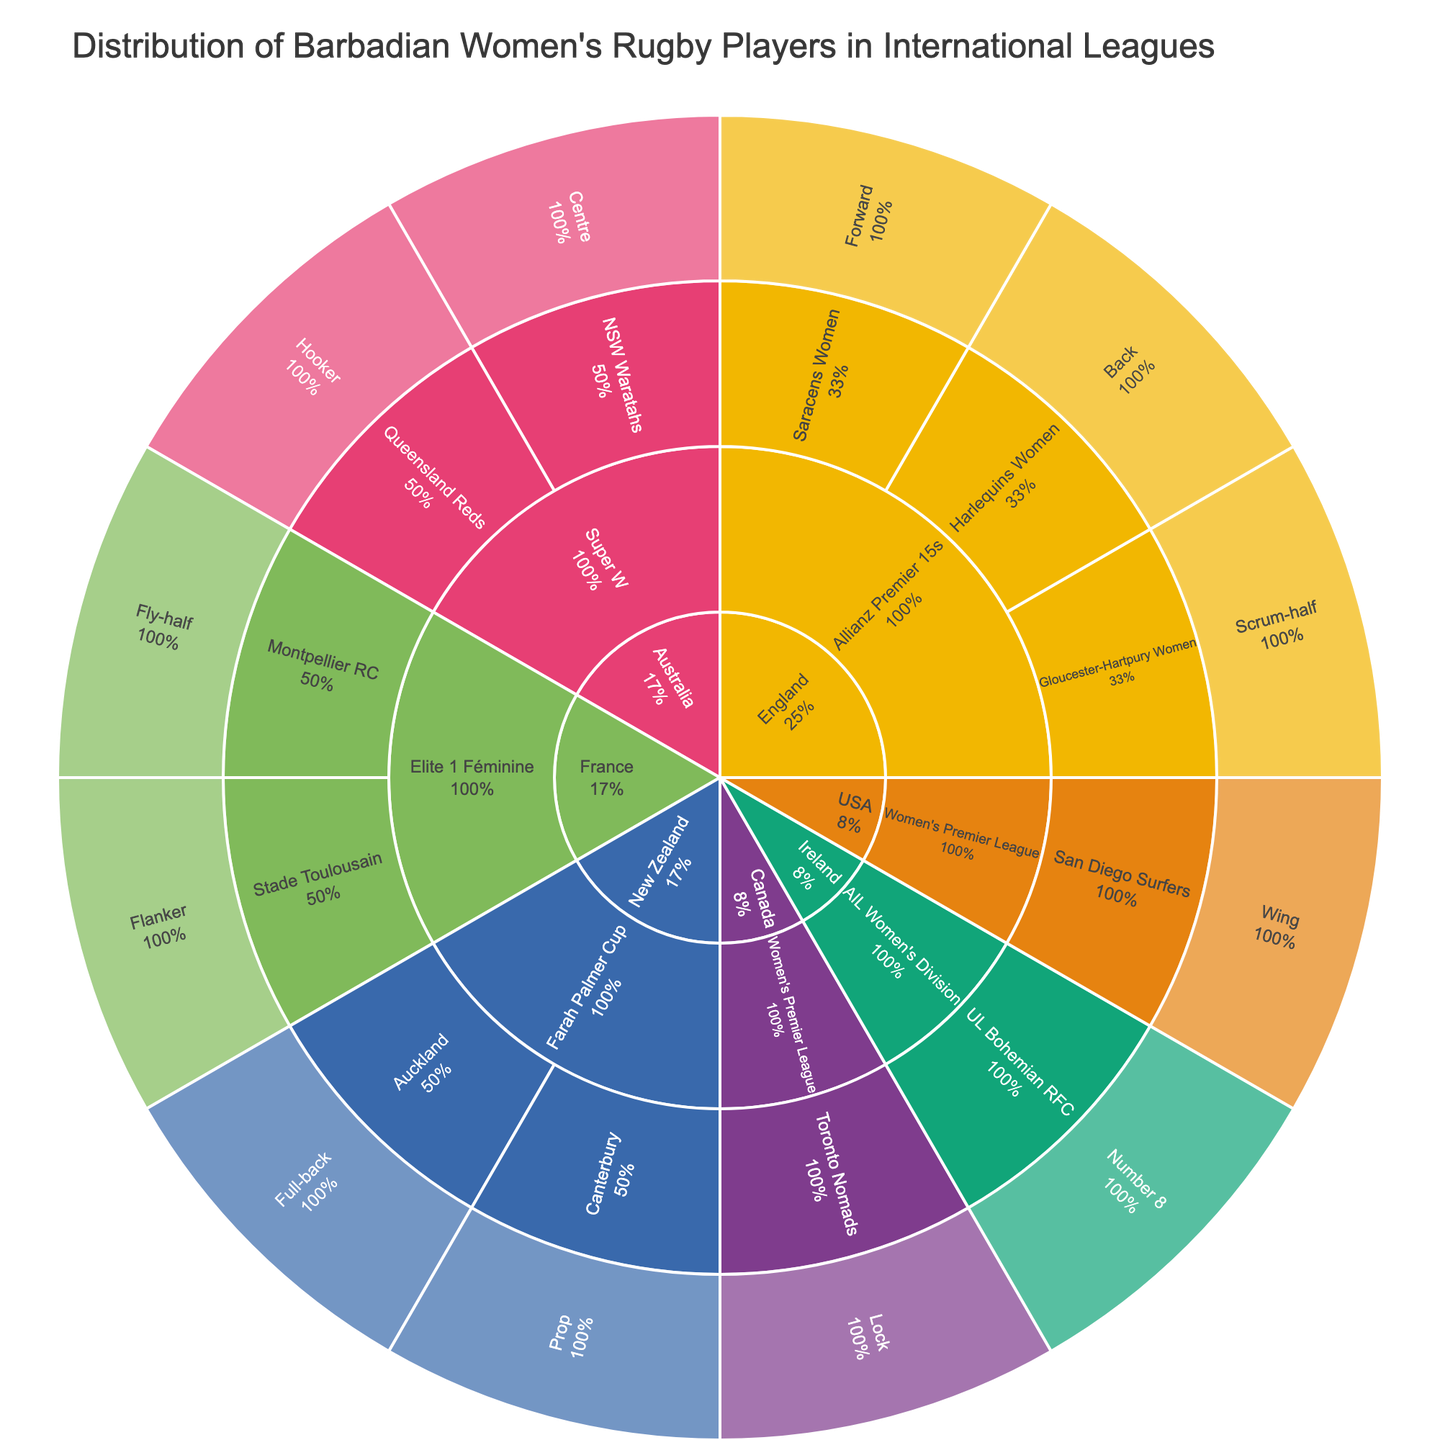How many countries have Barbadian women's rugby players in international leagues? The sunburst plot has 5 top-level segments representing countries with Barbadian women's rugby players in international leagues: England, France, New Zealand, Australia, and the USA.
Answer: 5 Which country has the most leagues with Barbadian women's rugby players? By examining the next level of the sunburst plot from the center, England has the Allianz Premier 15s league, and France has the Elite 1 Féminine league. New Zealand, Australia, Canada, and the USA have one league each. So, the country with the most leagues is England, with one league.
Answer: England Which league in New Zealand has Barbadian women rugby players, and what teams are they part of? In the sunburst plot, under New Zealand, the Farah Palmer Cup league is listed. The two teams under this league are Canterbury and Auckland.
Answer: Farah Palmer Cup, Canterbury, Auckland How many different roles are represented in the Allianz Premier 15s league? By navigating from England to the Allianz Premier 15s segment in the sunburst plot and further to teams, it can be observed that the roles include Forward (Saracens Women), Back (Harlequins Women), and Scrum-half (Gloucester-Hartpury Women). This totals three distinct roles.
Answer: 3 Which team in France has a Barbadian player in the Flanker position? In the sunburst plot, under France, then under the Elite 1 Féminine league, the Stade Toulousain team is listed, showing the Flanker role.
Answer: Stade Toulousain Are there more forwards or backs in the Allianz Premier 15s league? From the sunburst plot under England and Allianz Premier 15s league, there is one Forward (Saracens Women) and one Back (Harlequins Women). Thus, there are as many Forwards as there are Backs.
Answer: Equal Which team in Australia has a Barbadian player in the Centre role? In the sunburst plot, under Australia and the Super W league, the NSW Waratahs team is listed with the Centre role.
Answer: NSW Waratahs 